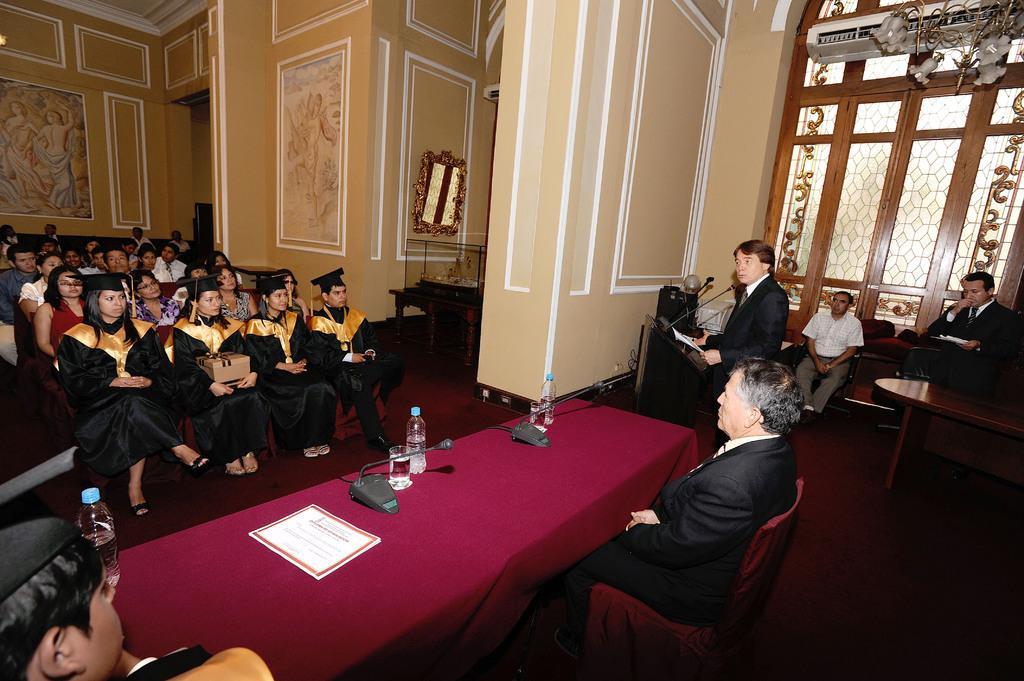In one or two sentences, can you explain what this image depicts? A man is standing and speaking at a podium. There are some people beside him. Two people are sitting at table beside him. There are some mic,water bottles and glasses on the table. There are some people sitting and listening to him. The hall is beautiful with paintings on the wall. There is a chandelier on top. 